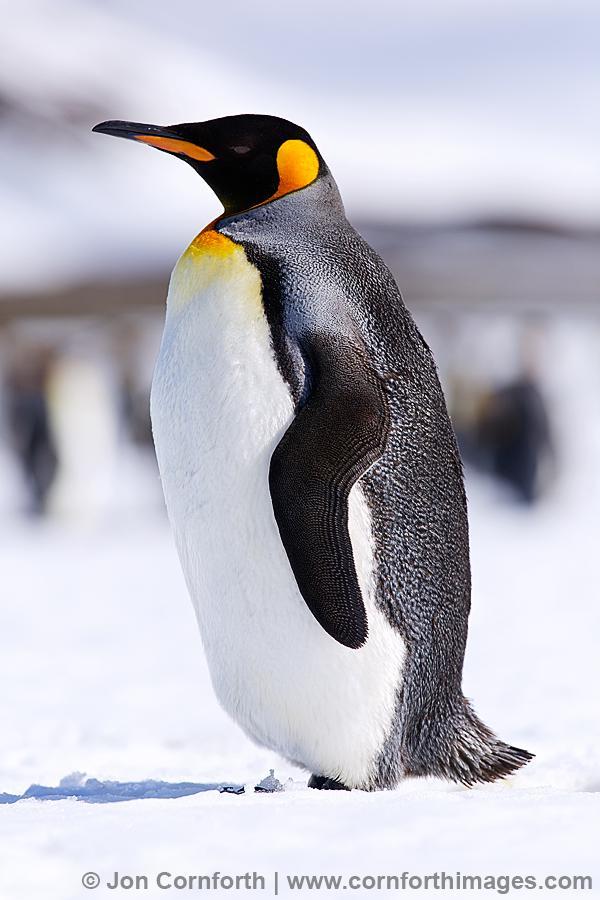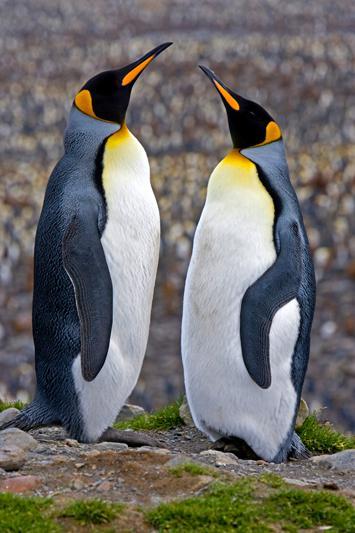The first image is the image on the left, the second image is the image on the right. For the images shown, is this caption "At least one image contains only two penguins facing each other." true? Answer yes or no. Yes. The first image is the image on the left, the second image is the image on the right. For the images displayed, is the sentence "There are no more than 4 penguins." factually correct? Answer yes or no. Yes. 